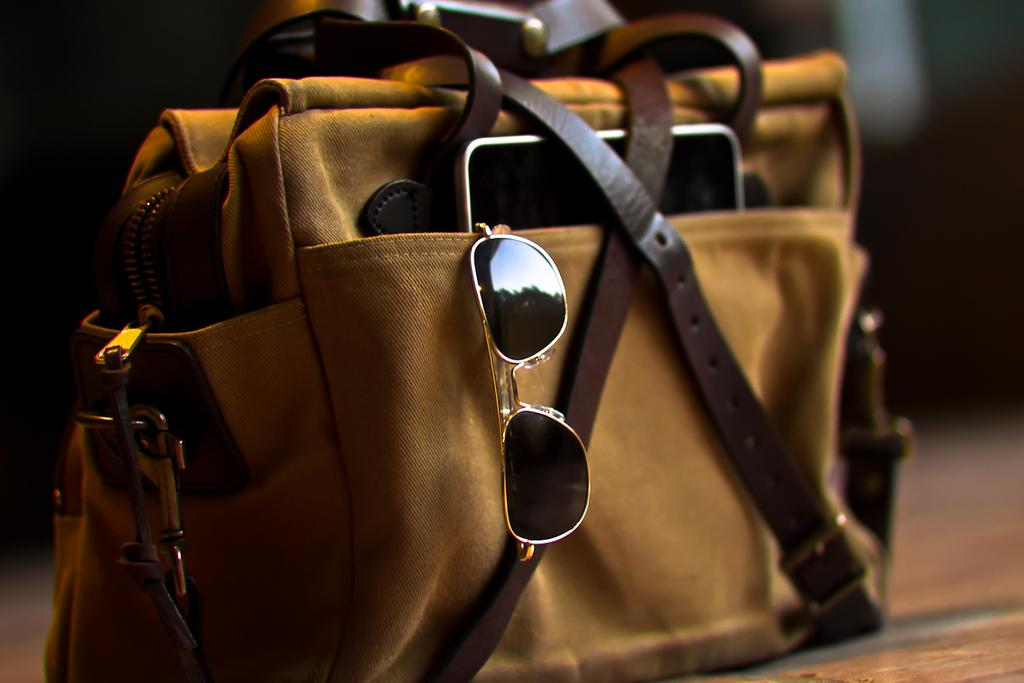What object is present in the image that can be used to carry items? There is a bag in the image that can be used to carry items. What color is the bag? The bag is yellow. What items can be found inside the bag? There is a mobile and goggles inside the bag. What is the color of the straps on the bag? The straps of the bag are brown. How many sails can be seen in the image? There are no sails present in the image. What type of number is written on the bag? There is no number written on the bag; it is a yellow bag with brown straps containing a mobile and goggles. 